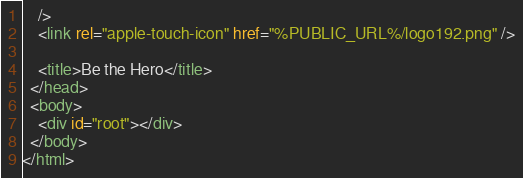<code> <loc_0><loc_0><loc_500><loc_500><_HTML_>    />
    <link rel="apple-touch-icon" href="%PUBLIC_URL%/logo192.png" />

    <title>Be the Hero</title>
  </head>
  <body>
    <div id="root"></div>
  </body>
</html>
</code> 